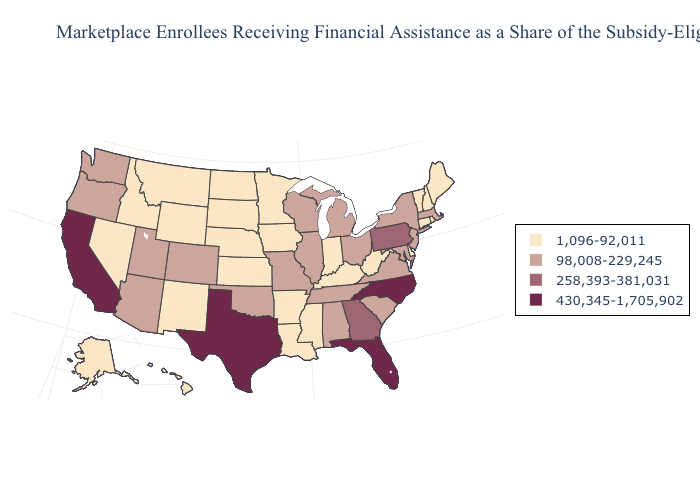Does the map have missing data?
Be succinct. No. What is the value of West Virginia?
Concise answer only. 1,096-92,011. Does South Dakota have a lower value than Louisiana?
Give a very brief answer. No. Does Maryland have the lowest value in the USA?
Keep it brief. No. What is the value of Iowa?
Write a very short answer. 1,096-92,011. Name the states that have a value in the range 430,345-1,705,902?
Concise answer only. California, Florida, North Carolina, Texas. What is the value of North Dakota?
Be succinct. 1,096-92,011. What is the value of North Carolina?
Concise answer only. 430,345-1,705,902. What is the value of New Hampshire?
Give a very brief answer. 1,096-92,011. Does the map have missing data?
Concise answer only. No. What is the value of Hawaii?
Concise answer only. 1,096-92,011. Name the states that have a value in the range 430,345-1,705,902?
Write a very short answer. California, Florida, North Carolina, Texas. Does the map have missing data?
Be succinct. No. How many symbols are there in the legend?
Write a very short answer. 4. Does Rhode Island have the highest value in the Northeast?
Be succinct. No. 